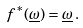Convert formula to latex. <formula><loc_0><loc_0><loc_500><loc_500>f ^ { \ast } ( \underline { \omega } ) = \underline { \omega } \, .</formula> 